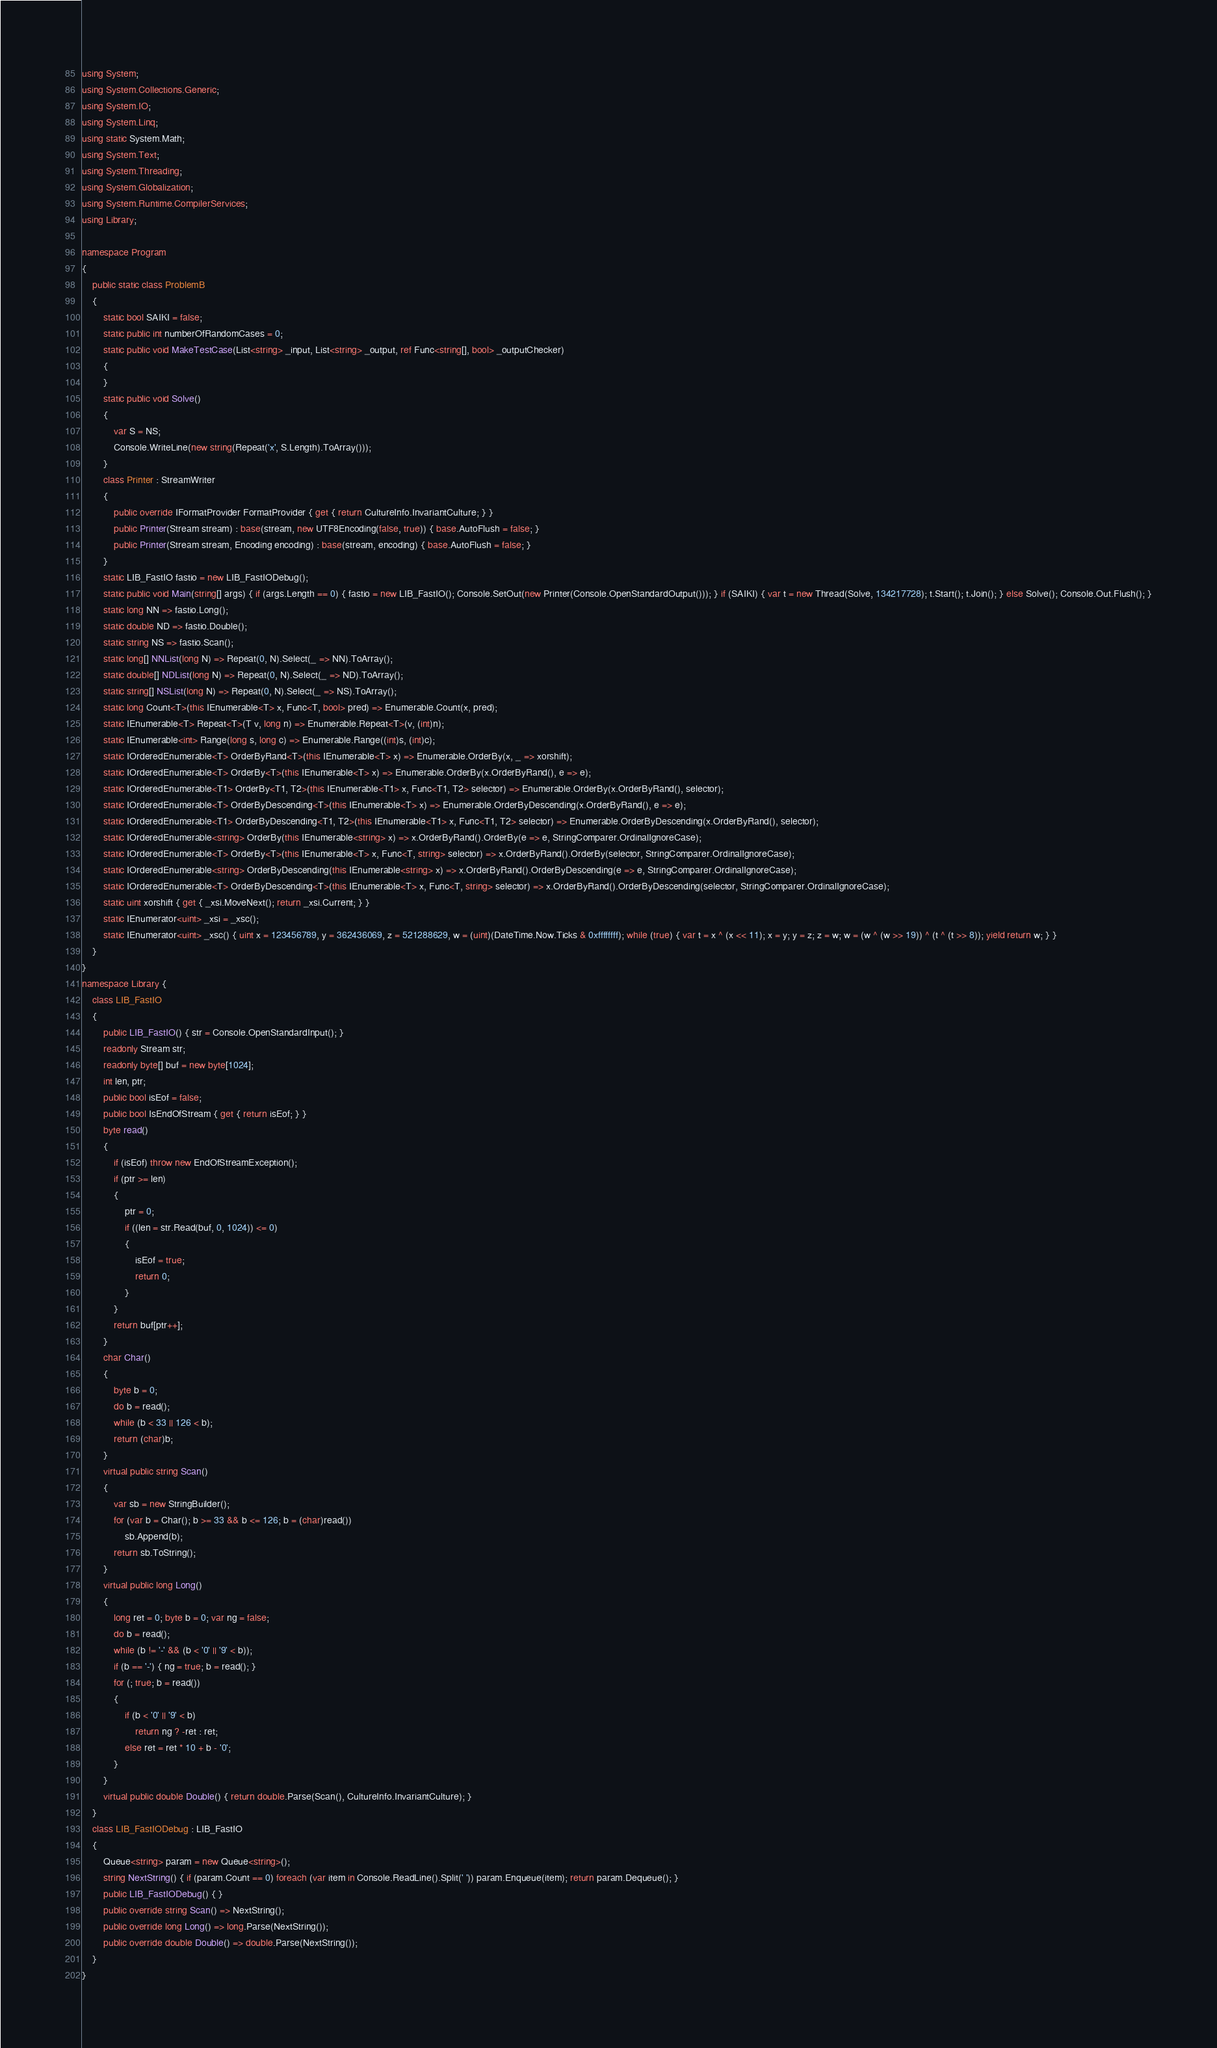Convert code to text. <code><loc_0><loc_0><loc_500><loc_500><_C#_>using System;
using System.Collections.Generic;
using System.IO;
using System.Linq;
using static System.Math;
using System.Text;
using System.Threading;
using System.Globalization;
using System.Runtime.CompilerServices;
using Library;

namespace Program
{
    public static class ProblemB
    {
        static bool SAIKI = false;
        static public int numberOfRandomCases = 0;
        static public void MakeTestCase(List<string> _input, List<string> _output, ref Func<string[], bool> _outputChecker)
        {
        }
        static public void Solve()
        {
            var S = NS;
            Console.WriteLine(new string(Repeat('x', S.Length).ToArray()));
        }
        class Printer : StreamWriter
        {
            public override IFormatProvider FormatProvider { get { return CultureInfo.InvariantCulture; } }
            public Printer(Stream stream) : base(stream, new UTF8Encoding(false, true)) { base.AutoFlush = false; }
            public Printer(Stream stream, Encoding encoding) : base(stream, encoding) { base.AutoFlush = false; }
        }
        static LIB_FastIO fastio = new LIB_FastIODebug();
        static public void Main(string[] args) { if (args.Length == 0) { fastio = new LIB_FastIO(); Console.SetOut(new Printer(Console.OpenStandardOutput())); } if (SAIKI) { var t = new Thread(Solve, 134217728); t.Start(); t.Join(); } else Solve(); Console.Out.Flush(); }
        static long NN => fastio.Long();
        static double ND => fastio.Double();
        static string NS => fastio.Scan();
        static long[] NNList(long N) => Repeat(0, N).Select(_ => NN).ToArray();
        static double[] NDList(long N) => Repeat(0, N).Select(_ => ND).ToArray();
        static string[] NSList(long N) => Repeat(0, N).Select(_ => NS).ToArray();
        static long Count<T>(this IEnumerable<T> x, Func<T, bool> pred) => Enumerable.Count(x, pred);
        static IEnumerable<T> Repeat<T>(T v, long n) => Enumerable.Repeat<T>(v, (int)n);
        static IEnumerable<int> Range(long s, long c) => Enumerable.Range((int)s, (int)c);
        static IOrderedEnumerable<T> OrderByRand<T>(this IEnumerable<T> x) => Enumerable.OrderBy(x, _ => xorshift);
        static IOrderedEnumerable<T> OrderBy<T>(this IEnumerable<T> x) => Enumerable.OrderBy(x.OrderByRand(), e => e);
        static IOrderedEnumerable<T1> OrderBy<T1, T2>(this IEnumerable<T1> x, Func<T1, T2> selector) => Enumerable.OrderBy(x.OrderByRand(), selector);
        static IOrderedEnumerable<T> OrderByDescending<T>(this IEnumerable<T> x) => Enumerable.OrderByDescending(x.OrderByRand(), e => e);
        static IOrderedEnumerable<T1> OrderByDescending<T1, T2>(this IEnumerable<T1> x, Func<T1, T2> selector) => Enumerable.OrderByDescending(x.OrderByRand(), selector);
        static IOrderedEnumerable<string> OrderBy(this IEnumerable<string> x) => x.OrderByRand().OrderBy(e => e, StringComparer.OrdinalIgnoreCase);
        static IOrderedEnumerable<T> OrderBy<T>(this IEnumerable<T> x, Func<T, string> selector) => x.OrderByRand().OrderBy(selector, StringComparer.OrdinalIgnoreCase);
        static IOrderedEnumerable<string> OrderByDescending(this IEnumerable<string> x) => x.OrderByRand().OrderByDescending(e => e, StringComparer.OrdinalIgnoreCase);
        static IOrderedEnumerable<T> OrderByDescending<T>(this IEnumerable<T> x, Func<T, string> selector) => x.OrderByRand().OrderByDescending(selector, StringComparer.OrdinalIgnoreCase);
        static uint xorshift { get { _xsi.MoveNext(); return _xsi.Current; } }
        static IEnumerator<uint> _xsi = _xsc();
        static IEnumerator<uint> _xsc() { uint x = 123456789, y = 362436069, z = 521288629, w = (uint)(DateTime.Now.Ticks & 0xffffffff); while (true) { var t = x ^ (x << 11); x = y; y = z; z = w; w = (w ^ (w >> 19)) ^ (t ^ (t >> 8)); yield return w; } }
    }
}
namespace Library {
    class LIB_FastIO
    {
        public LIB_FastIO() { str = Console.OpenStandardInput(); }
        readonly Stream str;
        readonly byte[] buf = new byte[1024];
        int len, ptr;
        public bool isEof = false;
        public bool IsEndOfStream { get { return isEof; } }
        byte read()
        {
            if (isEof) throw new EndOfStreamException();
            if (ptr >= len)
            {
                ptr = 0;
                if ((len = str.Read(buf, 0, 1024)) <= 0)
                {
                    isEof = true;
                    return 0;
                }
            }
            return buf[ptr++];
        }
        char Char()
        {
            byte b = 0;
            do b = read();
            while (b < 33 || 126 < b);
            return (char)b;
        }
        virtual public string Scan()
        {
            var sb = new StringBuilder();
            for (var b = Char(); b >= 33 && b <= 126; b = (char)read())
                sb.Append(b);
            return sb.ToString();
        }
        virtual public long Long()
        {
            long ret = 0; byte b = 0; var ng = false;
            do b = read();
            while (b != '-' && (b < '0' || '9' < b));
            if (b == '-') { ng = true; b = read(); }
            for (; true; b = read())
            {
                if (b < '0' || '9' < b)
                    return ng ? -ret : ret;
                else ret = ret * 10 + b - '0';
            }
        }
        virtual public double Double() { return double.Parse(Scan(), CultureInfo.InvariantCulture); }
    }
    class LIB_FastIODebug : LIB_FastIO
    {
        Queue<string> param = new Queue<string>();
        string NextString() { if (param.Count == 0) foreach (var item in Console.ReadLine().Split(' ')) param.Enqueue(item); return param.Dequeue(); }
        public LIB_FastIODebug() { }
        public override string Scan() => NextString();
        public override long Long() => long.Parse(NextString());
        public override double Double() => double.Parse(NextString());
    }
}
</code> 